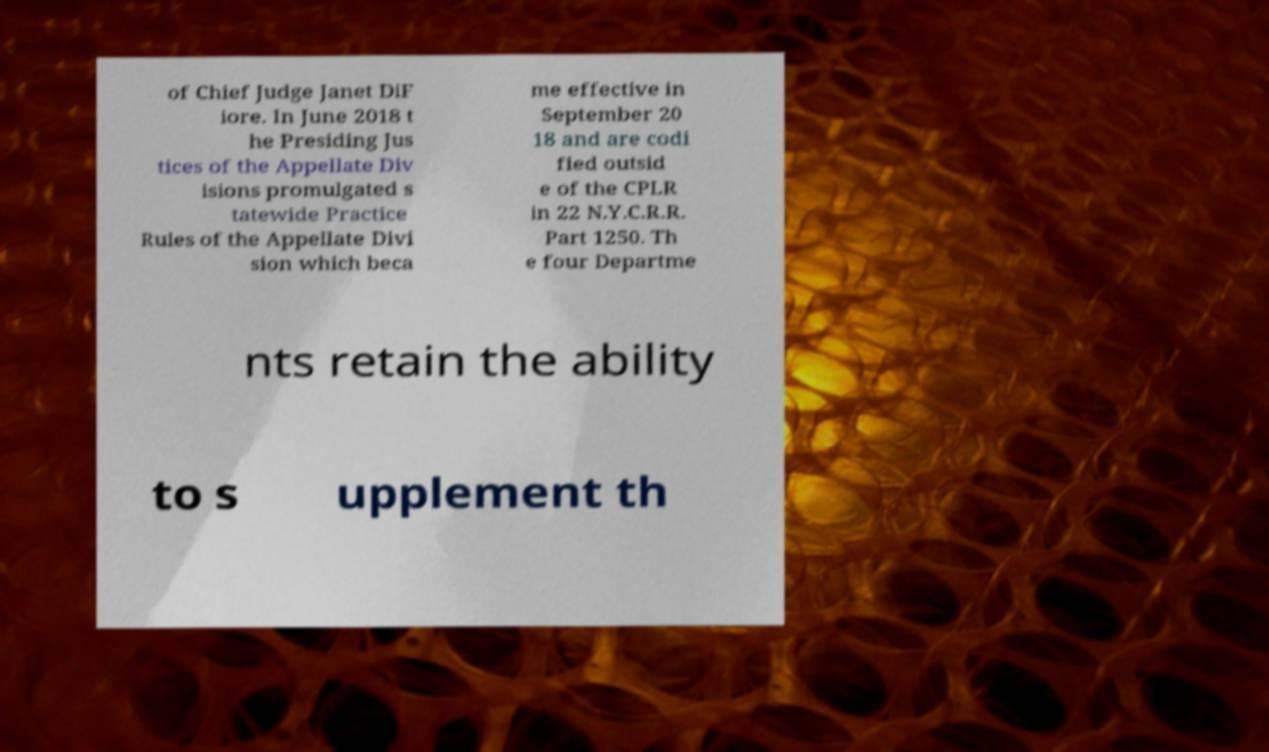Could you extract and type out the text from this image? of Chief Judge Janet DiF iore. In June 2018 t he Presiding Jus tices of the Appellate Div isions promulgated s tatewide Practice Rules of the Appellate Divi sion which beca me effective in September 20 18 and are codi fied outsid e of the CPLR in 22 N.Y.C.R.R. Part 1250. Th e four Departme nts retain the ability to s upplement th 